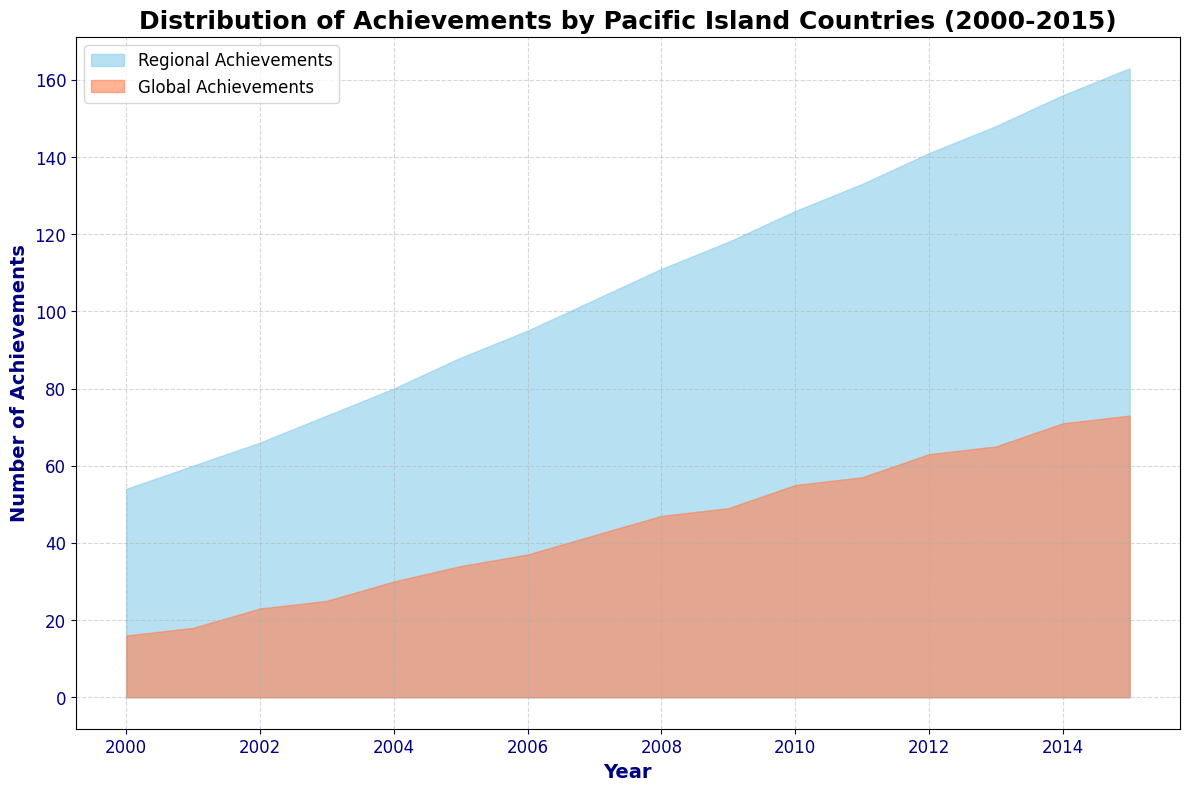What is the overall trend in the number of Regional Achievements from 2000 to 2015? The area representing Regional Achievements gradually increases from 2000 to 2015, indicating an overall upward trend.
Answer: An upward trend What year did Global Achievements reach a peak value? By observing the area chart section for Global Achievements, the peak appears to be around 2015.
Answer: 2015 How do the Regional Achievements in 2005 compare to those in 2010? Look at the height of the area for Regional Achievements in 2005 and 2010. The chart indicates that achievements in 2010 are higher than in 2005.
Answer: Higher in 2010 In what year did Global Achievements first reach double digits? Observing the height of the area for Global Achievements, we see that it first reaches double digits in 2004.
Answer: 2004 By how much did Fiji's Global Achievements increase from 2000 to 2015? Comparing the values directly from the data table, Fiji's Global Achievements increased from 5 in 2000 to 19 in 2015. The difference is 19 - 5.
Answer: 14 Which country had the smallest increment in Regional Achievements from 2000 to 2015? Refer to the data table and calculate the increments for each country. Vanuatu had the smallest change, going from 4 in 2000 to 18 in 2015, which is an increment of 14.
Answer: Vanuatu Which had a higher count of achievements each year on average, Regional or Global? Sum the total achievements over the years and then divide by the number of years for both categories. Regional Achievements consistently have a significantly higher average due to the larger area on the chart.
Answer: Regional Achievements What is the difference between the total Regional Achievements and the total Global Achievements in 2011? From the table, Regional Achievements in 2011 sum up to 36+21+19+27+16+14=133 and Global Achievements are 15+9+7+15+6+5=57, hence the difference is 133-57.
Answer: 76 How does the growth rate of Regional Achievements compare to that of Global Achievements over time? The area for both types grows, but Regional Achievements show a consistent and steeper upward trajectory compared to Global Achievements which also grow but at a more moderate pace.
Answer: Faster growth for Regional Achievements Which set of achievements, Regional or Global, showed less variability in their annual totals over the period observed? By observing the steady nature of the area covered, it is evident that Regional Achievements show less variability with a consistent upward trend, whereas Global Achievements show slightly more variation.
Answer: Regional Achievements 